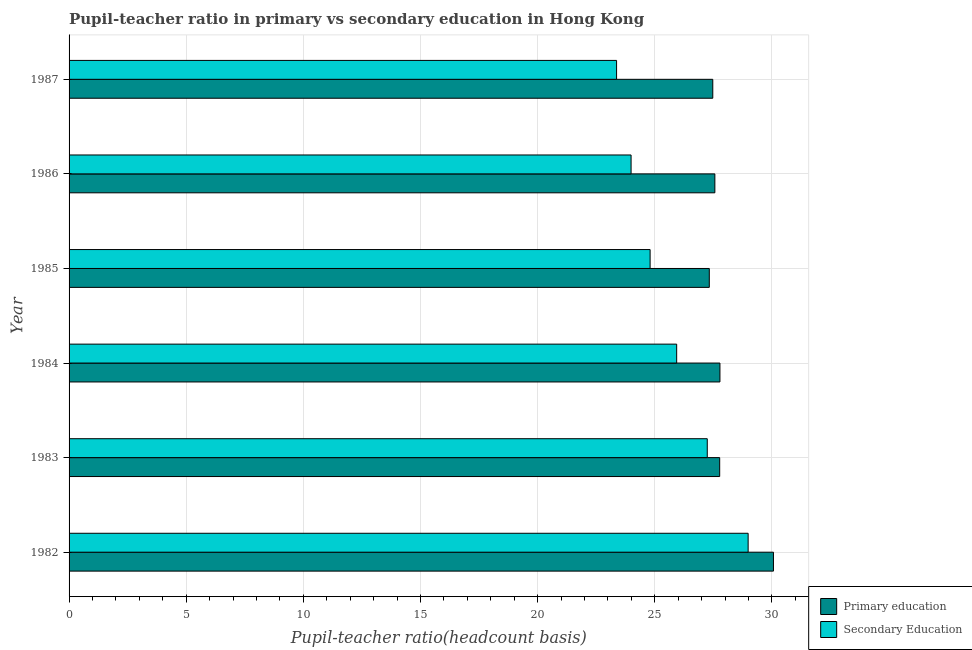How many groups of bars are there?
Keep it short and to the point. 6. How many bars are there on the 2nd tick from the top?
Make the answer very short. 2. In how many cases, is the number of bars for a given year not equal to the number of legend labels?
Provide a succinct answer. 0. What is the pupil teacher ratio on secondary education in 1985?
Offer a very short reply. 24.8. Across all years, what is the maximum pupil-teacher ratio in primary education?
Make the answer very short. 30.07. Across all years, what is the minimum pupil-teacher ratio in primary education?
Ensure brevity in your answer.  27.33. In which year was the pupil-teacher ratio in primary education maximum?
Give a very brief answer. 1982. What is the total pupil-teacher ratio in primary education in the graph?
Ensure brevity in your answer.  168. What is the difference between the pupil teacher ratio on secondary education in 1982 and that in 1983?
Your answer should be compact. 1.74. What is the difference between the pupil teacher ratio on secondary education in 1984 and the pupil-teacher ratio in primary education in 1983?
Ensure brevity in your answer.  -1.84. What is the average pupil-teacher ratio in primary education per year?
Your answer should be very brief. 28. In the year 1985, what is the difference between the pupil teacher ratio on secondary education and pupil-teacher ratio in primary education?
Provide a short and direct response. -2.53. In how many years, is the pupil teacher ratio on secondary education greater than 5 ?
Make the answer very short. 6. What is the ratio of the pupil-teacher ratio in primary education in 1983 to that in 1986?
Keep it short and to the point. 1.01. Is the pupil teacher ratio on secondary education in 1982 less than that in 1984?
Your answer should be compact. No. What is the difference between the highest and the second highest pupil-teacher ratio in primary education?
Offer a terse response. 2.28. What is the difference between the highest and the lowest pupil teacher ratio on secondary education?
Keep it short and to the point. 5.62. In how many years, is the pupil-teacher ratio in primary education greater than the average pupil-teacher ratio in primary education taken over all years?
Your answer should be compact. 1. Is the sum of the pupil teacher ratio on secondary education in 1983 and 1987 greater than the maximum pupil-teacher ratio in primary education across all years?
Provide a succinct answer. Yes. What does the 2nd bar from the top in 1982 represents?
Offer a terse response. Primary education. What does the 2nd bar from the bottom in 1983 represents?
Ensure brevity in your answer.  Secondary Education. Are the values on the major ticks of X-axis written in scientific E-notation?
Provide a short and direct response. No. Does the graph contain any zero values?
Offer a very short reply. No. Does the graph contain grids?
Provide a short and direct response. Yes. How many legend labels are there?
Provide a succinct answer. 2. What is the title of the graph?
Offer a very short reply. Pupil-teacher ratio in primary vs secondary education in Hong Kong. What is the label or title of the X-axis?
Offer a very short reply. Pupil-teacher ratio(headcount basis). What is the label or title of the Y-axis?
Your answer should be very brief. Year. What is the Pupil-teacher ratio(headcount basis) of Primary education in 1982?
Keep it short and to the point. 30.07. What is the Pupil-teacher ratio(headcount basis) of Secondary Education in 1982?
Your answer should be very brief. 28.99. What is the Pupil-teacher ratio(headcount basis) in Primary education in 1983?
Ensure brevity in your answer.  27.77. What is the Pupil-teacher ratio(headcount basis) in Secondary Education in 1983?
Your answer should be compact. 27.24. What is the Pupil-teacher ratio(headcount basis) of Primary education in 1984?
Offer a very short reply. 27.78. What is the Pupil-teacher ratio(headcount basis) of Secondary Education in 1984?
Your response must be concise. 25.94. What is the Pupil-teacher ratio(headcount basis) of Primary education in 1985?
Make the answer very short. 27.33. What is the Pupil-teacher ratio(headcount basis) of Secondary Education in 1985?
Provide a short and direct response. 24.8. What is the Pupil-teacher ratio(headcount basis) of Primary education in 1986?
Ensure brevity in your answer.  27.57. What is the Pupil-teacher ratio(headcount basis) in Secondary Education in 1986?
Your response must be concise. 23.99. What is the Pupil-teacher ratio(headcount basis) of Primary education in 1987?
Your answer should be very brief. 27.48. What is the Pupil-teacher ratio(headcount basis) in Secondary Education in 1987?
Make the answer very short. 23.37. Across all years, what is the maximum Pupil-teacher ratio(headcount basis) in Primary education?
Provide a succinct answer. 30.07. Across all years, what is the maximum Pupil-teacher ratio(headcount basis) in Secondary Education?
Your answer should be very brief. 28.99. Across all years, what is the minimum Pupil-teacher ratio(headcount basis) in Primary education?
Give a very brief answer. 27.33. Across all years, what is the minimum Pupil-teacher ratio(headcount basis) of Secondary Education?
Offer a terse response. 23.37. What is the total Pupil-teacher ratio(headcount basis) of Primary education in the graph?
Provide a short and direct response. 168. What is the total Pupil-teacher ratio(headcount basis) of Secondary Education in the graph?
Your response must be concise. 154.33. What is the difference between the Pupil-teacher ratio(headcount basis) of Primary education in 1982 and that in 1983?
Provide a short and direct response. 2.29. What is the difference between the Pupil-teacher ratio(headcount basis) of Secondary Education in 1982 and that in 1983?
Provide a short and direct response. 1.74. What is the difference between the Pupil-teacher ratio(headcount basis) of Primary education in 1982 and that in 1984?
Your answer should be very brief. 2.28. What is the difference between the Pupil-teacher ratio(headcount basis) in Secondary Education in 1982 and that in 1984?
Your response must be concise. 3.05. What is the difference between the Pupil-teacher ratio(headcount basis) of Primary education in 1982 and that in 1985?
Provide a succinct answer. 2.74. What is the difference between the Pupil-teacher ratio(headcount basis) of Secondary Education in 1982 and that in 1985?
Your answer should be very brief. 4.18. What is the difference between the Pupil-teacher ratio(headcount basis) of Primary education in 1982 and that in 1986?
Provide a short and direct response. 2.5. What is the difference between the Pupil-teacher ratio(headcount basis) of Secondary Education in 1982 and that in 1986?
Your answer should be very brief. 5. What is the difference between the Pupil-teacher ratio(headcount basis) of Primary education in 1982 and that in 1987?
Make the answer very short. 2.59. What is the difference between the Pupil-teacher ratio(headcount basis) in Secondary Education in 1982 and that in 1987?
Provide a short and direct response. 5.62. What is the difference between the Pupil-teacher ratio(headcount basis) of Primary education in 1983 and that in 1984?
Your answer should be very brief. -0.01. What is the difference between the Pupil-teacher ratio(headcount basis) in Secondary Education in 1983 and that in 1984?
Provide a succinct answer. 1.31. What is the difference between the Pupil-teacher ratio(headcount basis) of Primary education in 1983 and that in 1985?
Offer a terse response. 0.44. What is the difference between the Pupil-teacher ratio(headcount basis) in Secondary Education in 1983 and that in 1985?
Keep it short and to the point. 2.44. What is the difference between the Pupil-teacher ratio(headcount basis) of Primary education in 1983 and that in 1986?
Provide a succinct answer. 0.21. What is the difference between the Pupil-teacher ratio(headcount basis) of Secondary Education in 1983 and that in 1986?
Your response must be concise. 3.25. What is the difference between the Pupil-teacher ratio(headcount basis) of Primary education in 1983 and that in 1987?
Make the answer very short. 0.3. What is the difference between the Pupil-teacher ratio(headcount basis) in Secondary Education in 1983 and that in 1987?
Offer a terse response. 3.87. What is the difference between the Pupil-teacher ratio(headcount basis) in Primary education in 1984 and that in 1985?
Give a very brief answer. 0.45. What is the difference between the Pupil-teacher ratio(headcount basis) in Secondary Education in 1984 and that in 1985?
Make the answer very short. 1.13. What is the difference between the Pupil-teacher ratio(headcount basis) of Primary education in 1984 and that in 1986?
Make the answer very short. 0.22. What is the difference between the Pupil-teacher ratio(headcount basis) in Secondary Education in 1984 and that in 1986?
Make the answer very short. 1.95. What is the difference between the Pupil-teacher ratio(headcount basis) of Primary education in 1984 and that in 1987?
Give a very brief answer. 0.31. What is the difference between the Pupil-teacher ratio(headcount basis) of Secondary Education in 1984 and that in 1987?
Provide a succinct answer. 2.57. What is the difference between the Pupil-teacher ratio(headcount basis) in Primary education in 1985 and that in 1986?
Provide a succinct answer. -0.24. What is the difference between the Pupil-teacher ratio(headcount basis) in Secondary Education in 1985 and that in 1986?
Offer a very short reply. 0.81. What is the difference between the Pupil-teacher ratio(headcount basis) in Primary education in 1985 and that in 1987?
Your answer should be compact. -0.15. What is the difference between the Pupil-teacher ratio(headcount basis) in Secondary Education in 1985 and that in 1987?
Ensure brevity in your answer.  1.43. What is the difference between the Pupil-teacher ratio(headcount basis) of Primary education in 1986 and that in 1987?
Make the answer very short. 0.09. What is the difference between the Pupil-teacher ratio(headcount basis) of Secondary Education in 1986 and that in 1987?
Your answer should be compact. 0.62. What is the difference between the Pupil-teacher ratio(headcount basis) of Primary education in 1982 and the Pupil-teacher ratio(headcount basis) of Secondary Education in 1983?
Your response must be concise. 2.82. What is the difference between the Pupil-teacher ratio(headcount basis) in Primary education in 1982 and the Pupil-teacher ratio(headcount basis) in Secondary Education in 1984?
Offer a terse response. 4.13. What is the difference between the Pupil-teacher ratio(headcount basis) in Primary education in 1982 and the Pupil-teacher ratio(headcount basis) in Secondary Education in 1985?
Your answer should be very brief. 5.26. What is the difference between the Pupil-teacher ratio(headcount basis) in Primary education in 1982 and the Pupil-teacher ratio(headcount basis) in Secondary Education in 1986?
Make the answer very short. 6.08. What is the difference between the Pupil-teacher ratio(headcount basis) in Primary education in 1982 and the Pupil-teacher ratio(headcount basis) in Secondary Education in 1987?
Make the answer very short. 6.7. What is the difference between the Pupil-teacher ratio(headcount basis) in Primary education in 1983 and the Pupil-teacher ratio(headcount basis) in Secondary Education in 1984?
Ensure brevity in your answer.  1.84. What is the difference between the Pupil-teacher ratio(headcount basis) in Primary education in 1983 and the Pupil-teacher ratio(headcount basis) in Secondary Education in 1985?
Your answer should be very brief. 2.97. What is the difference between the Pupil-teacher ratio(headcount basis) in Primary education in 1983 and the Pupil-teacher ratio(headcount basis) in Secondary Education in 1986?
Make the answer very short. 3.78. What is the difference between the Pupil-teacher ratio(headcount basis) of Primary education in 1983 and the Pupil-teacher ratio(headcount basis) of Secondary Education in 1987?
Your answer should be very brief. 4.4. What is the difference between the Pupil-teacher ratio(headcount basis) of Primary education in 1984 and the Pupil-teacher ratio(headcount basis) of Secondary Education in 1985?
Keep it short and to the point. 2.98. What is the difference between the Pupil-teacher ratio(headcount basis) of Primary education in 1984 and the Pupil-teacher ratio(headcount basis) of Secondary Education in 1986?
Provide a short and direct response. 3.79. What is the difference between the Pupil-teacher ratio(headcount basis) in Primary education in 1984 and the Pupil-teacher ratio(headcount basis) in Secondary Education in 1987?
Keep it short and to the point. 4.41. What is the difference between the Pupil-teacher ratio(headcount basis) of Primary education in 1985 and the Pupil-teacher ratio(headcount basis) of Secondary Education in 1986?
Ensure brevity in your answer.  3.34. What is the difference between the Pupil-teacher ratio(headcount basis) of Primary education in 1985 and the Pupil-teacher ratio(headcount basis) of Secondary Education in 1987?
Your answer should be compact. 3.96. What is the difference between the Pupil-teacher ratio(headcount basis) in Primary education in 1986 and the Pupil-teacher ratio(headcount basis) in Secondary Education in 1987?
Ensure brevity in your answer.  4.2. What is the average Pupil-teacher ratio(headcount basis) of Primary education per year?
Make the answer very short. 28. What is the average Pupil-teacher ratio(headcount basis) in Secondary Education per year?
Your response must be concise. 25.72. In the year 1982, what is the difference between the Pupil-teacher ratio(headcount basis) of Primary education and Pupil-teacher ratio(headcount basis) of Secondary Education?
Make the answer very short. 1.08. In the year 1983, what is the difference between the Pupil-teacher ratio(headcount basis) of Primary education and Pupil-teacher ratio(headcount basis) of Secondary Education?
Offer a terse response. 0.53. In the year 1984, what is the difference between the Pupil-teacher ratio(headcount basis) of Primary education and Pupil-teacher ratio(headcount basis) of Secondary Education?
Offer a very short reply. 1.85. In the year 1985, what is the difference between the Pupil-teacher ratio(headcount basis) in Primary education and Pupil-teacher ratio(headcount basis) in Secondary Education?
Offer a very short reply. 2.53. In the year 1986, what is the difference between the Pupil-teacher ratio(headcount basis) in Primary education and Pupil-teacher ratio(headcount basis) in Secondary Education?
Offer a very short reply. 3.58. In the year 1987, what is the difference between the Pupil-teacher ratio(headcount basis) of Primary education and Pupil-teacher ratio(headcount basis) of Secondary Education?
Make the answer very short. 4.11. What is the ratio of the Pupil-teacher ratio(headcount basis) of Primary education in 1982 to that in 1983?
Keep it short and to the point. 1.08. What is the ratio of the Pupil-teacher ratio(headcount basis) in Secondary Education in 1982 to that in 1983?
Provide a short and direct response. 1.06. What is the ratio of the Pupil-teacher ratio(headcount basis) of Primary education in 1982 to that in 1984?
Your answer should be compact. 1.08. What is the ratio of the Pupil-teacher ratio(headcount basis) of Secondary Education in 1982 to that in 1984?
Your answer should be very brief. 1.12. What is the ratio of the Pupil-teacher ratio(headcount basis) in Primary education in 1982 to that in 1985?
Offer a very short reply. 1.1. What is the ratio of the Pupil-teacher ratio(headcount basis) in Secondary Education in 1982 to that in 1985?
Provide a succinct answer. 1.17. What is the ratio of the Pupil-teacher ratio(headcount basis) in Primary education in 1982 to that in 1986?
Make the answer very short. 1.09. What is the ratio of the Pupil-teacher ratio(headcount basis) in Secondary Education in 1982 to that in 1986?
Make the answer very short. 1.21. What is the ratio of the Pupil-teacher ratio(headcount basis) of Primary education in 1982 to that in 1987?
Your response must be concise. 1.09. What is the ratio of the Pupil-teacher ratio(headcount basis) in Secondary Education in 1982 to that in 1987?
Your response must be concise. 1.24. What is the ratio of the Pupil-teacher ratio(headcount basis) in Secondary Education in 1983 to that in 1984?
Offer a terse response. 1.05. What is the ratio of the Pupil-teacher ratio(headcount basis) in Primary education in 1983 to that in 1985?
Provide a short and direct response. 1.02. What is the ratio of the Pupil-teacher ratio(headcount basis) of Secondary Education in 1983 to that in 1985?
Offer a very short reply. 1.1. What is the ratio of the Pupil-teacher ratio(headcount basis) in Primary education in 1983 to that in 1986?
Offer a terse response. 1.01. What is the ratio of the Pupil-teacher ratio(headcount basis) of Secondary Education in 1983 to that in 1986?
Your response must be concise. 1.14. What is the ratio of the Pupil-teacher ratio(headcount basis) of Primary education in 1983 to that in 1987?
Give a very brief answer. 1.01. What is the ratio of the Pupil-teacher ratio(headcount basis) in Secondary Education in 1983 to that in 1987?
Make the answer very short. 1.17. What is the ratio of the Pupil-teacher ratio(headcount basis) of Primary education in 1984 to that in 1985?
Give a very brief answer. 1.02. What is the ratio of the Pupil-teacher ratio(headcount basis) in Secondary Education in 1984 to that in 1985?
Offer a terse response. 1.05. What is the ratio of the Pupil-teacher ratio(headcount basis) in Primary education in 1984 to that in 1986?
Make the answer very short. 1.01. What is the ratio of the Pupil-teacher ratio(headcount basis) of Secondary Education in 1984 to that in 1986?
Your answer should be very brief. 1.08. What is the ratio of the Pupil-teacher ratio(headcount basis) of Primary education in 1984 to that in 1987?
Offer a very short reply. 1.01. What is the ratio of the Pupil-teacher ratio(headcount basis) in Secondary Education in 1984 to that in 1987?
Ensure brevity in your answer.  1.11. What is the ratio of the Pupil-teacher ratio(headcount basis) of Primary education in 1985 to that in 1986?
Provide a succinct answer. 0.99. What is the ratio of the Pupil-teacher ratio(headcount basis) of Secondary Education in 1985 to that in 1986?
Offer a very short reply. 1.03. What is the ratio of the Pupil-teacher ratio(headcount basis) of Secondary Education in 1985 to that in 1987?
Your answer should be very brief. 1.06. What is the ratio of the Pupil-teacher ratio(headcount basis) of Secondary Education in 1986 to that in 1987?
Provide a succinct answer. 1.03. What is the difference between the highest and the second highest Pupil-teacher ratio(headcount basis) in Primary education?
Provide a short and direct response. 2.28. What is the difference between the highest and the second highest Pupil-teacher ratio(headcount basis) of Secondary Education?
Your answer should be very brief. 1.74. What is the difference between the highest and the lowest Pupil-teacher ratio(headcount basis) of Primary education?
Provide a short and direct response. 2.74. What is the difference between the highest and the lowest Pupil-teacher ratio(headcount basis) of Secondary Education?
Provide a short and direct response. 5.62. 